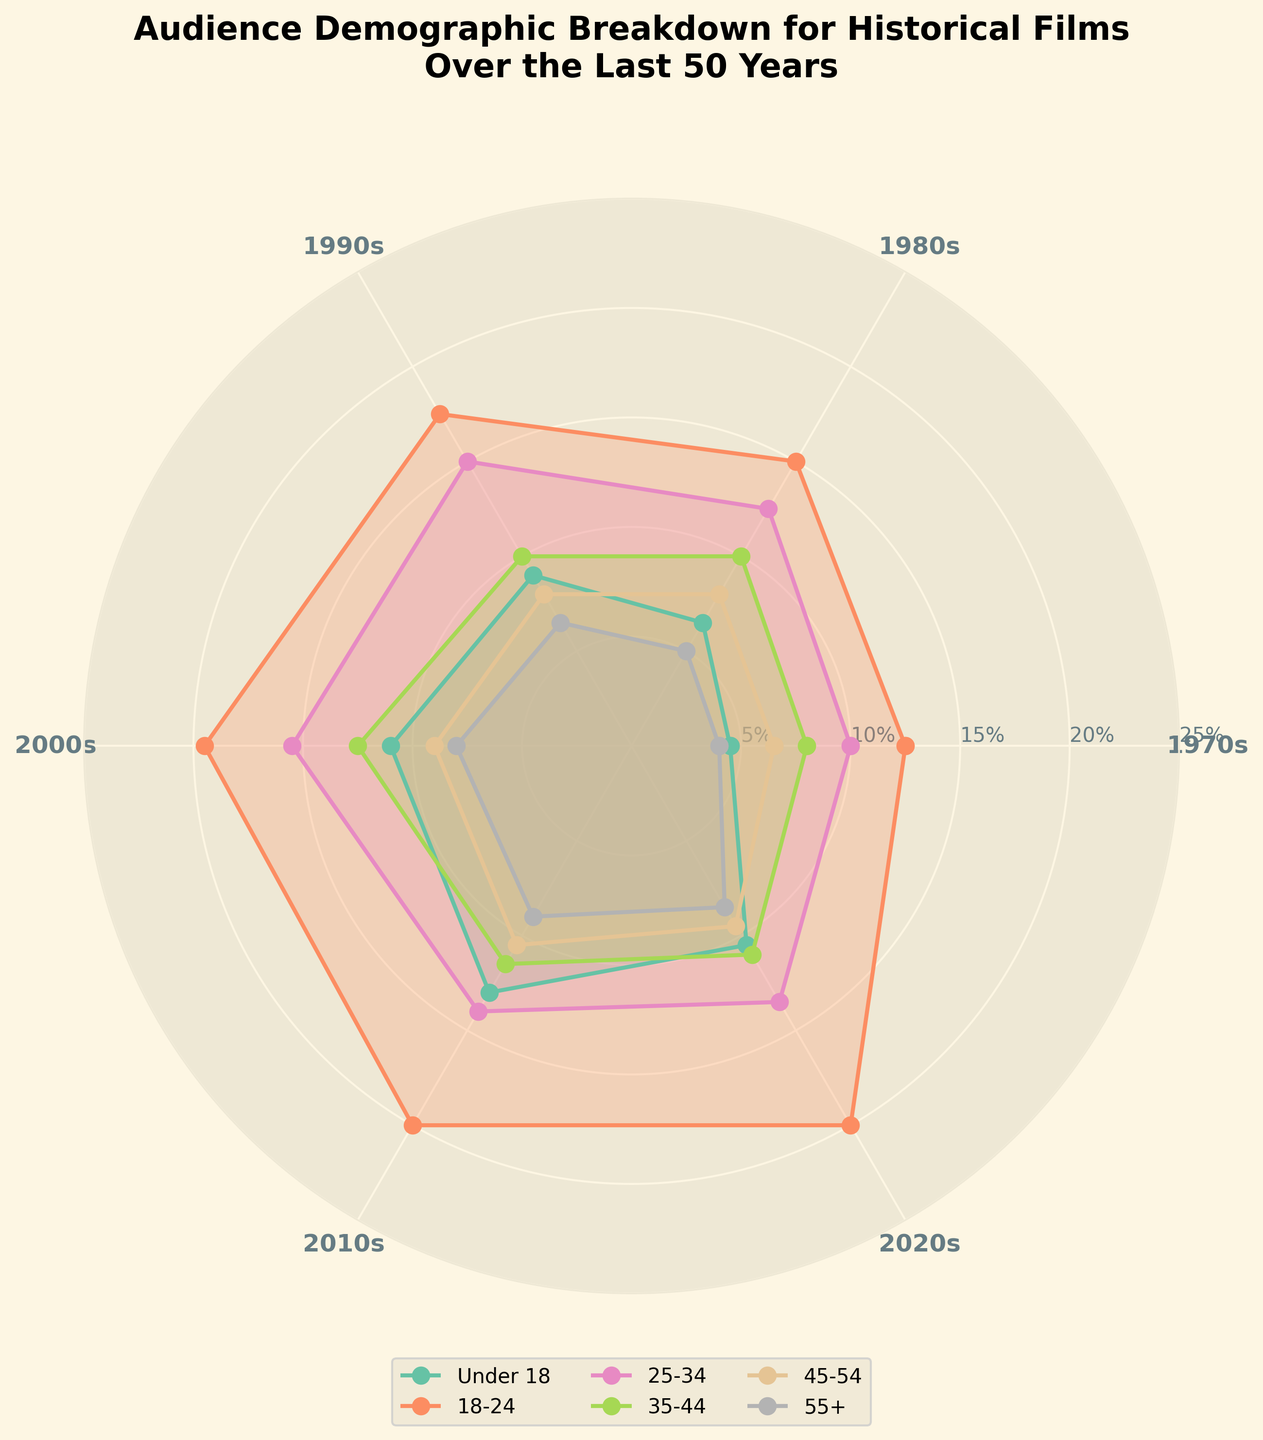What is the title of the figure? The title of the figure is displayed prominently at the top and reads, "Audience Demographic Breakdown for Historical Films Over the Last 50 Years."
Answer: Audience Demographic Breakdown for Historical Films Over the Last 50 Years How many age groups are represented in the figure? The figure shows lines and filled areas with different colors representing various age groups. There are a total of 6 labeled age categories.
Answer: 6 Which age group had the highest average male audience in the 2000s? By examining the lines and filled areas, the male age group 18-24 consistently shows a higher average value compared to other male age groups in the 2000s.
Answer: 18-24 In which decade did females aged 18-24 have their peak audience percentage? The plot for females aged 18-24 shows the maximum value among the decades. The highest point on the radial axis is in the 2020s.
Answer: 2020s What is the trend for the male audience aged Under 18 from the 1970s to 2020s? The angle lines representing male audiences under 18 show an increasing trend, starting from 5 in the 1970s and peaking around 2020. The pattern indicates fluctuations but an overall rise in percentage.
Answer: Increasing What is the difference in audience percentage between males aged 35-44 and 45-54 in the 2010s? By comparing the radial distances of the 35-44 and 45-54 age groups for males in the 2010s, males aged 35-44 have a value of 13 and those aged 45-54 have a value of 12. The difference is calculated as 13 - 12.
Answer: 1 Which gender and age group had the lowest average audience percentage across all decades? The figure shows the shaded areas and lines where females aged 55+ appear to have the lowest radial values consistently across all decades.
Answer: Female, 55+ Between the 1990s and 2010s, which gender and age group saw the largest increase in audience percentage? By comparing the radial lines, females aged 18-24 demonstrate a significant increase in their percentage from the 1990s to the 2010s. The line for this group shows considerable growth between those decades.
Answer: Female, 18-24 Do the male and female audiences under 18 follow similar trends over the decades? By comparing the patterns of the lines for male and female audiences under 18, they both show an overall increasing trend, although males start at a slightly higher percentage and fluctuate more.
Answer: Yes How does the audience percentage for females aged 25-34 change from the 2000s to the 2020s? Examining the radial lines and filled patterns for females aged 25-34, the values show an increase from 14 in the 2000s to 15 in the 2020s, indicating a slight growth over the decades.
Answer: Increase from 14 to 15 